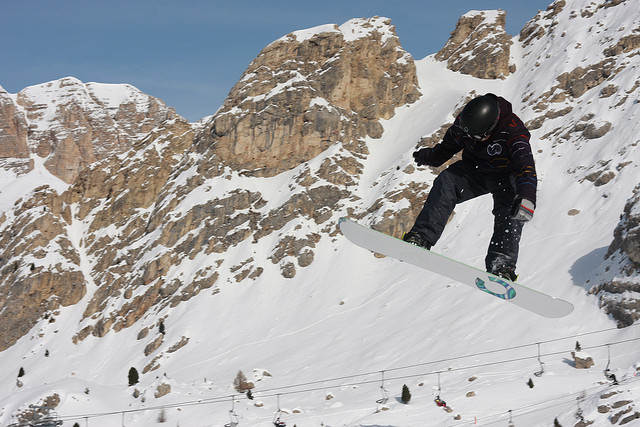Are there any trees or vegetation visible? No, there are no trees or any noticeable vegetation in the image. The environment is dominated by rocky terrain and snow-covered surfaces, typical of high-altitude alpine regions. 